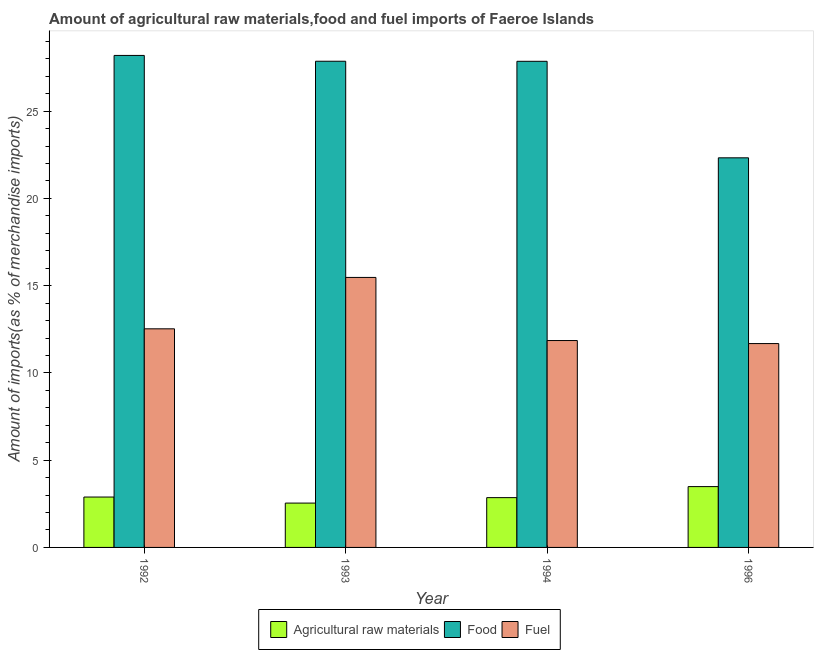How many groups of bars are there?
Keep it short and to the point. 4. Are the number of bars per tick equal to the number of legend labels?
Keep it short and to the point. Yes. How many bars are there on the 2nd tick from the left?
Provide a short and direct response. 3. How many bars are there on the 2nd tick from the right?
Your answer should be very brief. 3. What is the label of the 1st group of bars from the left?
Provide a succinct answer. 1992. In how many cases, is the number of bars for a given year not equal to the number of legend labels?
Ensure brevity in your answer.  0. What is the percentage of raw materials imports in 1992?
Make the answer very short. 2.89. Across all years, what is the maximum percentage of fuel imports?
Provide a succinct answer. 15.47. Across all years, what is the minimum percentage of raw materials imports?
Offer a very short reply. 2.54. In which year was the percentage of fuel imports minimum?
Keep it short and to the point. 1996. What is the total percentage of raw materials imports in the graph?
Provide a succinct answer. 11.77. What is the difference between the percentage of raw materials imports in 1992 and that in 1994?
Give a very brief answer. 0.03. What is the difference between the percentage of raw materials imports in 1992 and the percentage of food imports in 1994?
Offer a terse response. 0.03. What is the average percentage of raw materials imports per year?
Offer a very short reply. 2.94. In how many years, is the percentage of fuel imports greater than 13 %?
Offer a very short reply. 1. What is the ratio of the percentage of raw materials imports in 1992 to that in 1993?
Provide a short and direct response. 1.14. Is the percentage of fuel imports in 1994 less than that in 1996?
Make the answer very short. No. Is the difference between the percentage of fuel imports in 1992 and 1993 greater than the difference between the percentage of food imports in 1992 and 1993?
Provide a short and direct response. No. What is the difference between the highest and the second highest percentage of fuel imports?
Your answer should be very brief. 2.95. What is the difference between the highest and the lowest percentage of raw materials imports?
Offer a terse response. 0.94. Is the sum of the percentage of raw materials imports in 1992 and 1996 greater than the maximum percentage of fuel imports across all years?
Your response must be concise. Yes. What does the 2nd bar from the left in 1992 represents?
Ensure brevity in your answer.  Food. What does the 3rd bar from the right in 1994 represents?
Ensure brevity in your answer.  Agricultural raw materials. Are all the bars in the graph horizontal?
Keep it short and to the point. No. What is the difference between two consecutive major ticks on the Y-axis?
Offer a terse response. 5. Where does the legend appear in the graph?
Keep it short and to the point. Bottom center. How are the legend labels stacked?
Make the answer very short. Horizontal. What is the title of the graph?
Offer a very short reply. Amount of agricultural raw materials,food and fuel imports of Faeroe Islands. What is the label or title of the Y-axis?
Your answer should be very brief. Amount of imports(as % of merchandise imports). What is the Amount of imports(as % of merchandise imports) of Agricultural raw materials in 1992?
Provide a short and direct response. 2.89. What is the Amount of imports(as % of merchandise imports) in Food in 1992?
Give a very brief answer. 28.19. What is the Amount of imports(as % of merchandise imports) in Fuel in 1992?
Provide a short and direct response. 12.53. What is the Amount of imports(as % of merchandise imports) in Agricultural raw materials in 1993?
Make the answer very short. 2.54. What is the Amount of imports(as % of merchandise imports) of Food in 1993?
Provide a short and direct response. 27.86. What is the Amount of imports(as % of merchandise imports) in Fuel in 1993?
Offer a terse response. 15.47. What is the Amount of imports(as % of merchandise imports) in Agricultural raw materials in 1994?
Provide a succinct answer. 2.85. What is the Amount of imports(as % of merchandise imports) in Food in 1994?
Provide a succinct answer. 27.86. What is the Amount of imports(as % of merchandise imports) of Fuel in 1994?
Offer a terse response. 11.85. What is the Amount of imports(as % of merchandise imports) of Agricultural raw materials in 1996?
Your response must be concise. 3.48. What is the Amount of imports(as % of merchandise imports) in Food in 1996?
Provide a succinct answer. 22.33. What is the Amount of imports(as % of merchandise imports) in Fuel in 1996?
Your answer should be compact. 11.68. Across all years, what is the maximum Amount of imports(as % of merchandise imports) in Agricultural raw materials?
Ensure brevity in your answer.  3.48. Across all years, what is the maximum Amount of imports(as % of merchandise imports) of Food?
Ensure brevity in your answer.  28.19. Across all years, what is the maximum Amount of imports(as % of merchandise imports) of Fuel?
Provide a short and direct response. 15.47. Across all years, what is the minimum Amount of imports(as % of merchandise imports) in Agricultural raw materials?
Keep it short and to the point. 2.54. Across all years, what is the minimum Amount of imports(as % of merchandise imports) of Food?
Your answer should be compact. 22.33. Across all years, what is the minimum Amount of imports(as % of merchandise imports) of Fuel?
Keep it short and to the point. 11.68. What is the total Amount of imports(as % of merchandise imports) of Agricultural raw materials in the graph?
Keep it short and to the point. 11.77. What is the total Amount of imports(as % of merchandise imports) of Food in the graph?
Provide a short and direct response. 106.23. What is the total Amount of imports(as % of merchandise imports) in Fuel in the graph?
Provide a succinct answer. 51.53. What is the difference between the Amount of imports(as % of merchandise imports) in Agricultural raw materials in 1992 and that in 1993?
Keep it short and to the point. 0.35. What is the difference between the Amount of imports(as % of merchandise imports) in Food in 1992 and that in 1993?
Keep it short and to the point. 0.33. What is the difference between the Amount of imports(as % of merchandise imports) in Fuel in 1992 and that in 1993?
Ensure brevity in your answer.  -2.95. What is the difference between the Amount of imports(as % of merchandise imports) in Agricultural raw materials in 1992 and that in 1994?
Your answer should be very brief. 0.03. What is the difference between the Amount of imports(as % of merchandise imports) in Food in 1992 and that in 1994?
Offer a terse response. 0.34. What is the difference between the Amount of imports(as % of merchandise imports) in Fuel in 1992 and that in 1994?
Give a very brief answer. 0.67. What is the difference between the Amount of imports(as % of merchandise imports) of Agricultural raw materials in 1992 and that in 1996?
Your answer should be compact. -0.6. What is the difference between the Amount of imports(as % of merchandise imports) in Food in 1992 and that in 1996?
Your response must be concise. 5.87. What is the difference between the Amount of imports(as % of merchandise imports) of Fuel in 1992 and that in 1996?
Keep it short and to the point. 0.84. What is the difference between the Amount of imports(as % of merchandise imports) in Agricultural raw materials in 1993 and that in 1994?
Make the answer very short. -0.31. What is the difference between the Amount of imports(as % of merchandise imports) of Food in 1993 and that in 1994?
Keep it short and to the point. 0. What is the difference between the Amount of imports(as % of merchandise imports) in Fuel in 1993 and that in 1994?
Make the answer very short. 3.62. What is the difference between the Amount of imports(as % of merchandise imports) of Agricultural raw materials in 1993 and that in 1996?
Provide a succinct answer. -0.94. What is the difference between the Amount of imports(as % of merchandise imports) in Food in 1993 and that in 1996?
Your response must be concise. 5.53. What is the difference between the Amount of imports(as % of merchandise imports) in Fuel in 1993 and that in 1996?
Your answer should be very brief. 3.79. What is the difference between the Amount of imports(as % of merchandise imports) in Agricultural raw materials in 1994 and that in 1996?
Offer a very short reply. -0.63. What is the difference between the Amount of imports(as % of merchandise imports) in Food in 1994 and that in 1996?
Keep it short and to the point. 5.53. What is the difference between the Amount of imports(as % of merchandise imports) of Fuel in 1994 and that in 1996?
Give a very brief answer. 0.17. What is the difference between the Amount of imports(as % of merchandise imports) of Agricultural raw materials in 1992 and the Amount of imports(as % of merchandise imports) of Food in 1993?
Ensure brevity in your answer.  -24.97. What is the difference between the Amount of imports(as % of merchandise imports) of Agricultural raw materials in 1992 and the Amount of imports(as % of merchandise imports) of Fuel in 1993?
Offer a terse response. -12.58. What is the difference between the Amount of imports(as % of merchandise imports) in Food in 1992 and the Amount of imports(as % of merchandise imports) in Fuel in 1993?
Your response must be concise. 12.72. What is the difference between the Amount of imports(as % of merchandise imports) of Agricultural raw materials in 1992 and the Amount of imports(as % of merchandise imports) of Food in 1994?
Your answer should be very brief. -24.97. What is the difference between the Amount of imports(as % of merchandise imports) in Agricultural raw materials in 1992 and the Amount of imports(as % of merchandise imports) in Fuel in 1994?
Ensure brevity in your answer.  -8.97. What is the difference between the Amount of imports(as % of merchandise imports) in Food in 1992 and the Amount of imports(as % of merchandise imports) in Fuel in 1994?
Offer a very short reply. 16.34. What is the difference between the Amount of imports(as % of merchandise imports) in Agricultural raw materials in 1992 and the Amount of imports(as % of merchandise imports) in Food in 1996?
Make the answer very short. -19.44. What is the difference between the Amount of imports(as % of merchandise imports) in Agricultural raw materials in 1992 and the Amount of imports(as % of merchandise imports) in Fuel in 1996?
Offer a terse response. -8.79. What is the difference between the Amount of imports(as % of merchandise imports) of Food in 1992 and the Amount of imports(as % of merchandise imports) of Fuel in 1996?
Your response must be concise. 16.51. What is the difference between the Amount of imports(as % of merchandise imports) in Agricultural raw materials in 1993 and the Amount of imports(as % of merchandise imports) in Food in 1994?
Offer a very short reply. -25.32. What is the difference between the Amount of imports(as % of merchandise imports) in Agricultural raw materials in 1993 and the Amount of imports(as % of merchandise imports) in Fuel in 1994?
Keep it short and to the point. -9.31. What is the difference between the Amount of imports(as % of merchandise imports) of Food in 1993 and the Amount of imports(as % of merchandise imports) of Fuel in 1994?
Provide a short and direct response. 16. What is the difference between the Amount of imports(as % of merchandise imports) in Agricultural raw materials in 1993 and the Amount of imports(as % of merchandise imports) in Food in 1996?
Your answer should be compact. -19.78. What is the difference between the Amount of imports(as % of merchandise imports) of Agricultural raw materials in 1993 and the Amount of imports(as % of merchandise imports) of Fuel in 1996?
Offer a terse response. -9.14. What is the difference between the Amount of imports(as % of merchandise imports) in Food in 1993 and the Amount of imports(as % of merchandise imports) in Fuel in 1996?
Ensure brevity in your answer.  16.18. What is the difference between the Amount of imports(as % of merchandise imports) of Agricultural raw materials in 1994 and the Amount of imports(as % of merchandise imports) of Food in 1996?
Your answer should be very brief. -19.47. What is the difference between the Amount of imports(as % of merchandise imports) in Agricultural raw materials in 1994 and the Amount of imports(as % of merchandise imports) in Fuel in 1996?
Give a very brief answer. -8.83. What is the difference between the Amount of imports(as % of merchandise imports) of Food in 1994 and the Amount of imports(as % of merchandise imports) of Fuel in 1996?
Ensure brevity in your answer.  16.17. What is the average Amount of imports(as % of merchandise imports) of Agricultural raw materials per year?
Provide a short and direct response. 2.94. What is the average Amount of imports(as % of merchandise imports) of Food per year?
Provide a succinct answer. 26.56. What is the average Amount of imports(as % of merchandise imports) in Fuel per year?
Your answer should be compact. 12.88. In the year 1992, what is the difference between the Amount of imports(as % of merchandise imports) in Agricultural raw materials and Amount of imports(as % of merchandise imports) in Food?
Offer a very short reply. -25.31. In the year 1992, what is the difference between the Amount of imports(as % of merchandise imports) in Agricultural raw materials and Amount of imports(as % of merchandise imports) in Fuel?
Provide a short and direct response. -9.64. In the year 1992, what is the difference between the Amount of imports(as % of merchandise imports) of Food and Amount of imports(as % of merchandise imports) of Fuel?
Your answer should be compact. 15.67. In the year 1993, what is the difference between the Amount of imports(as % of merchandise imports) of Agricultural raw materials and Amount of imports(as % of merchandise imports) of Food?
Your response must be concise. -25.32. In the year 1993, what is the difference between the Amount of imports(as % of merchandise imports) of Agricultural raw materials and Amount of imports(as % of merchandise imports) of Fuel?
Your response must be concise. -12.93. In the year 1993, what is the difference between the Amount of imports(as % of merchandise imports) in Food and Amount of imports(as % of merchandise imports) in Fuel?
Your answer should be compact. 12.39. In the year 1994, what is the difference between the Amount of imports(as % of merchandise imports) of Agricultural raw materials and Amount of imports(as % of merchandise imports) of Food?
Offer a very short reply. -25. In the year 1994, what is the difference between the Amount of imports(as % of merchandise imports) of Agricultural raw materials and Amount of imports(as % of merchandise imports) of Fuel?
Provide a short and direct response. -9. In the year 1994, what is the difference between the Amount of imports(as % of merchandise imports) of Food and Amount of imports(as % of merchandise imports) of Fuel?
Your response must be concise. 16. In the year 1996, what is the difference between the Amount of imports(as % of merchandise imports) in Agricultural raw materials and Amount of imports(as % of merchandise imports) in Food?
Provide a succinct answer. -18.84. In the year 1996, what is the difference between the Amount of imports(as % of merchandise imports) in Agricultural raw materials and Amount of imports(as % of merchandise imports) in Fuel?
Offer a very short reply. -8.2. In the year 1996, what is the difference between the Amount of imports(as % of merchandise imports) of Food and Amount of imports(as % of merchandise imports) of Fuel?
Ensure brevity in your answer.  10.64. What is the ratio of the Amount of imports(as % of merchandise imports) in Agricultural raw materials in 1992 to that in 1993?
Your answer should be compact. 1.14. What is the ratio of the Amount of imports(as % of merchandise imports) in Fuel in 1992 to that in 1993?
Provide a short and direct response. 0.81. What is the ratio of the Amount of imports(as % of merchandise imports) in Food in 1992 to that in 1994?
Ensure brevity in your answer.  1.01. What is the ratio of the Amount of imports(as % of merchandise imports) of Fuel in 1992 to that in 1994?
Your answer should be very brief. 1.06. What is the ratio of the Amount of imports(as % of merchandise imports) in Agricultural raw materials in 1992 to that in 1996?
Offer a terse response. 0.83. What is the ratio of the Amount of imports(as % of merchandise imports) of Food in 1992 to that in 1996?
Offer a very short reply. 1.26. What is the ratio of the Amount of imports(as % of merchandise imports) in Fuel in 1992 to that in 1996?
Make the answer very short. 1.07. What is the ratio of the Amount of imports(as % of merchandise imports) in Agricultural raw materials in 1993 to that in 1994?
Provide a succinct answer. 0.89. What is the ratio of the Amount of imports(as % of merchandise imports) in Fuel in 1993 to that in 1994?
Keep it short and to the point. 1.31. What is the ratio of the Amount of imports(as % of merchandise imports) in Agricultural raw materials in 1993 to that in 1996?
Make the answer very short. 0.73. What is the ratio of the Amount of imports(as % of merchandise imports) in Food in 1993 to that in 1996?
Provide a short and direct response. 1.25. What is the ratio of the Amount of imports(as % of merchandise imports) in Fuel in 1993 to that in 1996?
Give a very brief answer. 1.32. What is the ratio of the Amount of imports(as % of merchandise imports) in Agricultural raw materials in 1994 to that in 1996?
Your answer should be compact. 0.82. What is the ratio of the Amount of imports(as % of merchandise imports) of Food in 1994 to that in 1996?
Give a very brief answer. 1.25. What is the ratio of the Amount of imports(as % of merchandise imports) of Fuel in 1994 to that in 1996?
Your answer should be very brief. 1.01. What is the difference between the highest and the second highest Amount of imports(as % of merchandise imports) of Agricultural raw materials?
Your answer should be very brief. 0.6. What is the difference between the highest and the second highest Amount of imports(as % of merchandise imports) of Food?
Make the answer very short. 0.33. What is the difference between the highest and the second highest Amount of imports(as % of merchandise imports) of Fuel?
Make the answer very short. 2.95. What is the difference between the highest and the lowest Amount of imports(as % of merchandise imports) of Agricultural raw materials?
Offer a terse response. 0.94. What is the difference between the highest and the lowest Amount of imports(as % of merchandise imports) in Food?
Ensure brevity in your answer.  5.87. What is the difference between the highest and the lowest Amount of imports(as % of merchandise imports) in Fuel?
Make the answer very short. 3.79. 